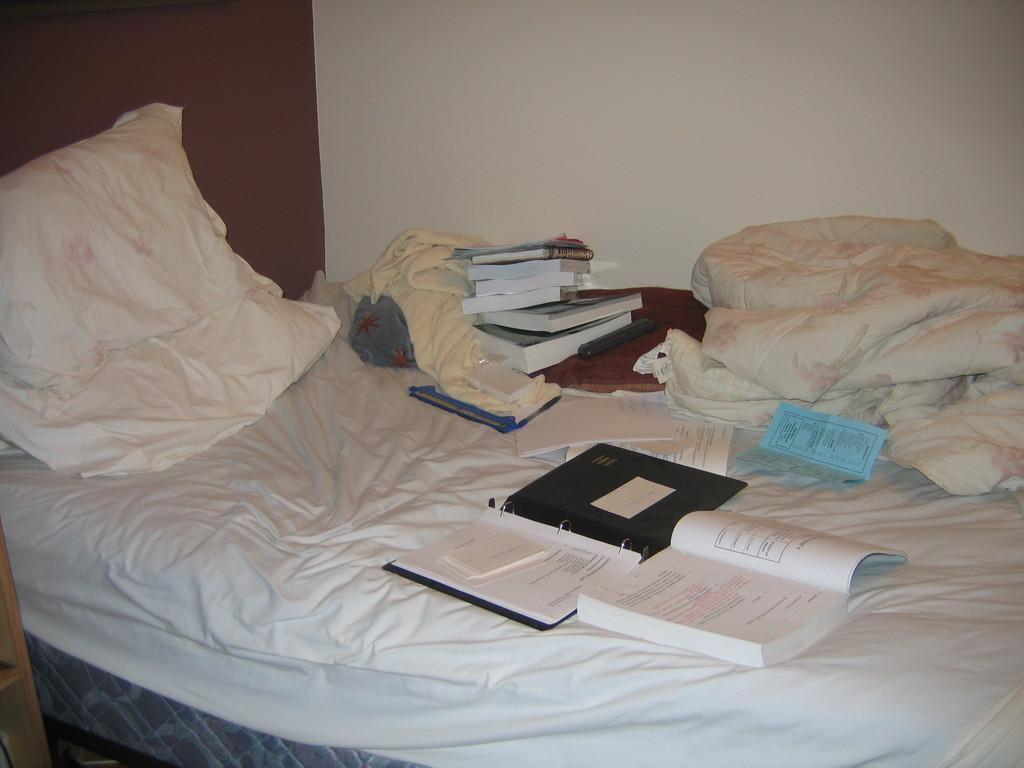What piece of furniture is in the image? There is a bed in the image. What is on top of the bed? There is a pillow on the bed. What else can be seen in the image besides the bed and pillow? Clothes, books, and other objects are present in the image. What is visible in the background of the image? There is a wall in the background of the image. Can you see a fang in the image? There is no fang present in the image. Is there a playground visible in the image? There is no playground visible in the image. 